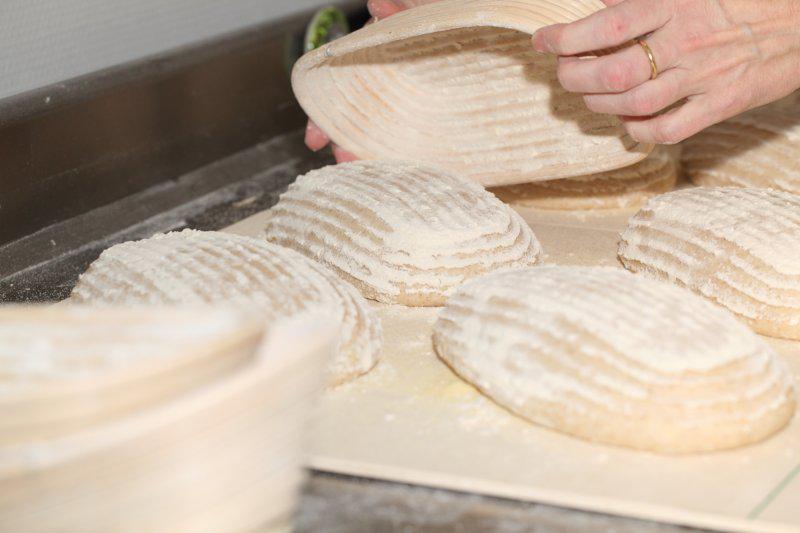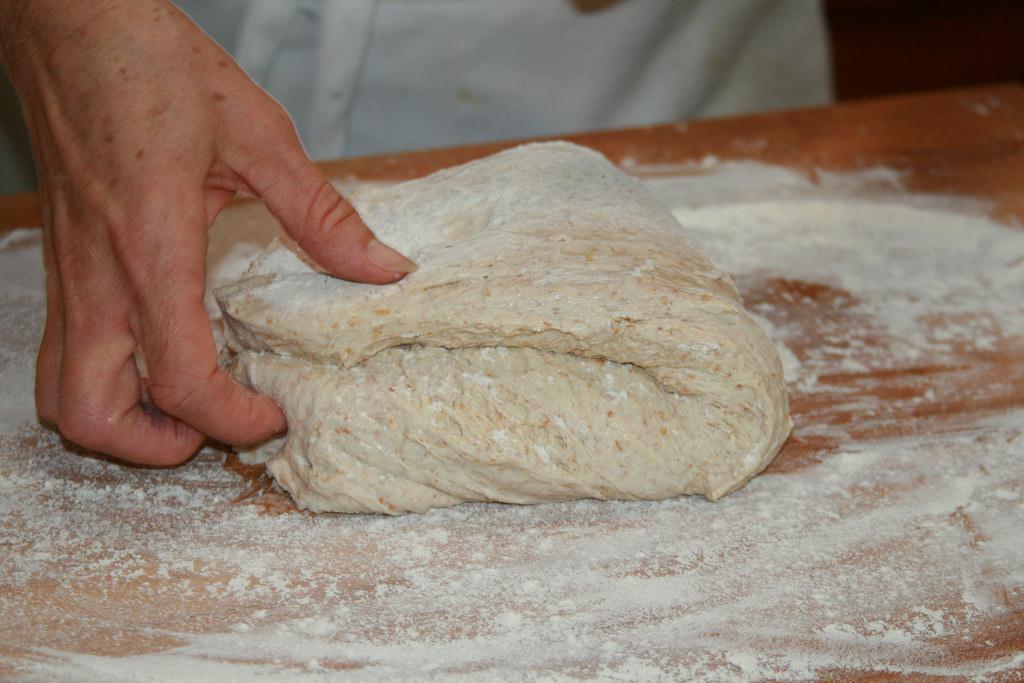The first image is the image on the left, the second image is the image on the right. Given the left and right images, does the statement "The combined images show a mound of dough on a floured wooden counter and dough being dumped out of a loaf pan with ribbed texture." hold true? Answer yes or no. Yes. The first image is the image on the left, the second image is the image on the right. Evaluate the accuracy of this statement regarding the images: "In one of the images, dough is being transferred out of a ceramic container.". Is it true? Answer yes or no. Yes. 